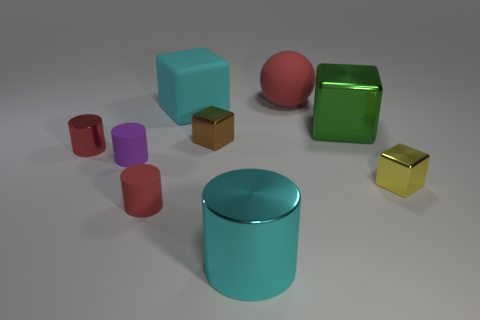Add 1 yellow cubes. How many objects exist? 10 Subtract all rubber blocks. How many blocks are left? 3 Subtract 2 cubes. How many cubes are left? 2 Subtract all yellow cubes. How many purple cylinders are left? 1 Subtract all rubber cubes. Subtract all tiny brown shiny objects. How many objects are left? 7 Add 7 small purple matte cylinders. How many small purple matte cylinders are left? 8 Add 5 tiny cubes. How many tiny cubes exist? 7 Subtract all green blocks. How many blocks are left? 3 Subtract 2 red cylinders. How many objects are left? 7 Subtract all spheres. How many objects are left? 8 